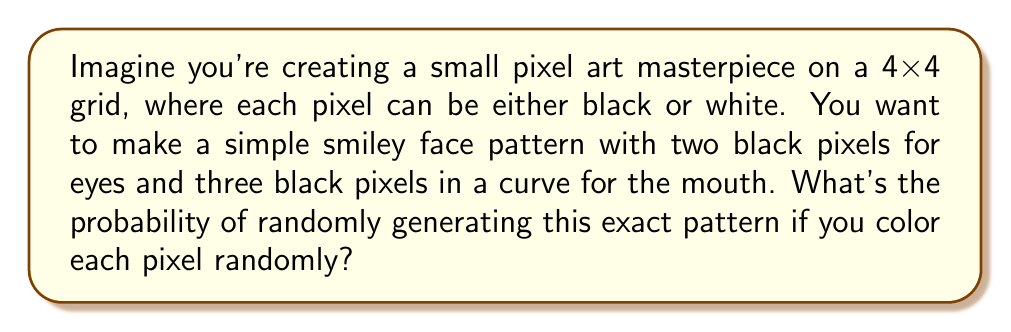What is the answer to this math problem? Let's approach this step-by-step:

1) First, we need to understand the total number of possibilities:
   - We have a 4x4 grid, so there are 16 pixels in total.
   - Each pixel can be either black or white.
   - Thus, the total number of possible patterns is $2^{16}$.

2) Now, let's consider our specific pattern:
   - We need exactly 5 black pixels (2 for eyes, 3 for mouth) in specific positions.
   - The remaining 11 pixels must be white.

3) To calculate the probability, we need to find:
   $$P(\text{specific pattern}) = \frac{\text{number of ways to create our specific pattern}}{\text{total number of possible patterns}}$$

4) For our specific pattern:
   - There's only 1 way to create it (the 5 black pixels and 11 white pixels must be in exact positions).
   - The total number of possible patterns is $2^{16}$, as calculated earlier.

5) Therefore, the probability is:
   $$P(\text{specific pattern}) = \frac{1}{2^{16}} = \frac{1}{65536}$$
Answer: $\frac{1}{65536}$ 